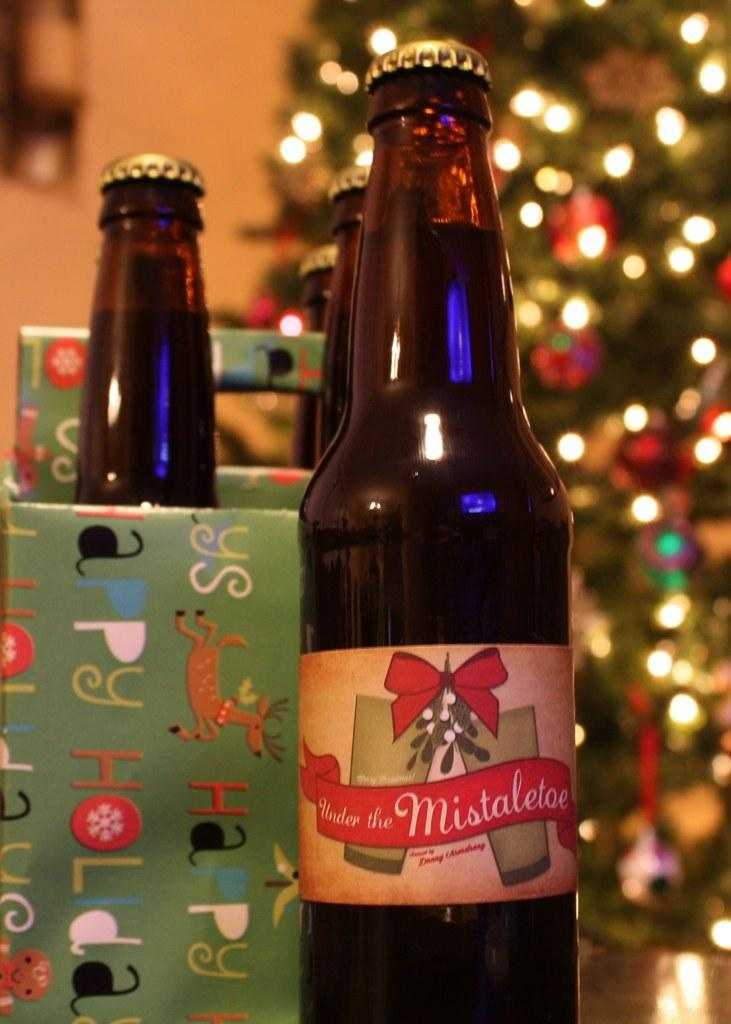Provide a one-sentence caption for the provided image. A bottle of Under the Miseltoe beer sits in front of a christmas tree. 